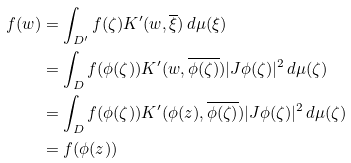<formula> <loc_0><loc_0><loc_500><loc_500>f ( w ) & = \int _ { D ^ { \prime } } f ( \zeta ) K ^ { \prime } ( w , \overline { \xi } ) \, d \mu ( \xi ) \\ & = \int _ { D } f ( \phi ( \zeta ) ) K ^ { \prime } ( w , \overline { \phi ( \zeta ) } ) | J \phi ( \zeta ) | ^ { 2 } \, d \mu ( \zeta ) \\ & = \int _ { D } f ( \phi ( \zeta ) ) K ^ { \prime } ( \phi ( z ) , \overline { \phi ( \zeta ) } ) | J \phi ( \zeta ) | ^ { 2 } \, d \mu ( \zeta ) \\ & = f ( \phi ( z ) )</formula> 